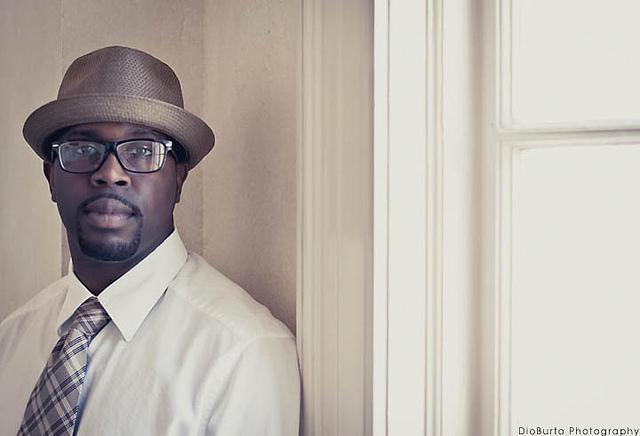How many horses are there?
Give a very brief answer. 0. 